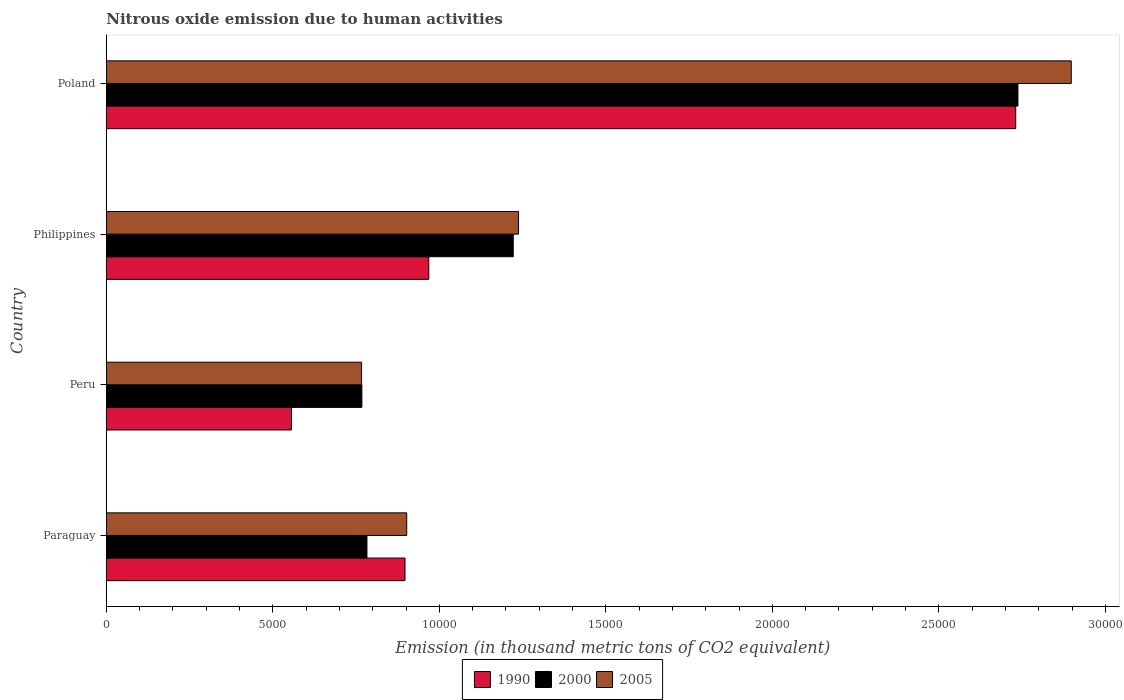Are the number of bars per tick equal to the number of legend labels?
Your answer should be very brief. Yes. How many bars are there on the 2nd tick from the bottom?
Your answer should be compact. 3. What is the label of the 2nd group of bars from the top?
Your answer should be very brief. Philippines. What is the amount of nitrous oxide emitted in 2000 in Philippines?
Ensure brevity in your answer.  1.22e+04. Across all countries, what is the maximum amount of nitrous oxide emitted in 2005?
Keep it short and to the point. 2.90e+04. Across all countries, what is the minimum amount of nitrous oxide emitted in 1990?
Your answer should be compact. 5559.3. What is the total amount of nitrous oxide emitted in 2000 in the graph?
Ensure brevity in your answer.  5.51e+04. What is the difference between the amount of nitrous oxide emitted in 2000 in Philippines and that in Poland?
Provide a short and direct response. -1.52e+04. What is the difference between the amount of nitrous oxide emitted in 2000 in Peru and the amount of nitrous oxide emitted in 2005 in Philippines?
Offer a terse response. -4704.2. What is the average amount of nitrous oxide emitted in 2005 per country?
Your answer should be very brief. 1.45e+04. What is the difference between the amount of nitrous oxide emitted in 2000 and amount of nitrous oxide emitted in 1990 in Poland?
Ensure brevity in your answer.  66.8. What is the ratio of the amount of nitrous oxide emitted in 2005 in Peru to that in Poland?
Offer a very short reply. 0.26. Is the difference between the amount of nitrous oxide emitted in 2000 in Paraguay and Poland greater than the difference between the amount of nitrous oxide emitted in 1990 in Paraguay and Poland?
Your answer should be very brief. No. What is the difference between the highest and the second highest amount of nitrous oxide emitted in 2005?
Make the answer very short. 1.66e+04. What is the difference between the highest and the lowest amount of nitrous oxide emitted in 2005?
Your answer should be very brief. 2.13e+04. What does the 3rd bar from the bottom in Poland represents?
Give a very brief answer. 2005. Is it the case that in every country, the sum of the amount of nitrous oxide emitted in 2000 and amount of nitrous oxide emitted in 1990 is greater than the amount of nitrous oxide emitted in 2005?
Provide a short and direct response. Yes. What is the difference between two consecutive major ticks on the X-axis?
Make the answer very short. 5000. Does the graph contain any zero values?
Your answer should be very brief. No. What is the title of the graph?
Your response must be concise. Nitrous oxide emission due to human activities. What is the label or title of the X-axis?
Your answer should be compact. Emission (in thousand metric tons of CO2 equivalent). What is the Emission (in thousand metric tons of CO2 equivalent) in 1990 in Paraguay?
Provide a short and direct response. 8968.7. What is the Emission (in thousand metric tons of CO2 equivalent) of 2000 in Paraguay?
Your answer should be very brief. 7826.3. What is the Emission (in thousand metric tons of CO2 equivalent) of 2005 in Paraguay?
Give a very brief answer. 9019.7. What is the Emission (in thousand metric tons of CO2 equivalent) in 1990 in Peru?
Provide a succinct answer. 5559.3. What is the Emission (in thousand metric tons of CO2 equivalent) of 2000 in Peru?
Make the answer very short. 7673.9. What is the Emission (in thousand metric tons of CO2 equivalent) in 2005 in Peru?
Make the answer very short. 7664.2. What is the Emission (in thousand metric tons of CO2 equivalent) in 1990 in Philippines?
Keep it short and to the point. 9682.8. What is the Emission (in thousand metric tons of CO2 equivalent) of 2000 in Philippines?
Your answer should be compact. 1.22e+04. What is the Emission (in thousand metric tons of CO2 equivalent) in 2005 in Philippines?
Provide a succinct answer. 1.24e+04. What is the Emission (in thousand metric tons of CO2 equivalent) of 1990 in Poland?
Offer a terse response. 2.73e+04. What is the Emission (in thousand metric tons of CO2 equivalent) in 2000 in Poland?
Give a very brief answer. 2.74e+04. What is the Emission (in thousand metric tons of CO2 equivalent) of 2005 in Poland?
Offer a very short reply. 2.90e+04. Across all countries, what is the maximum Emission (in thousand metric tons of CO2 equivalent) of 1990?
Provide a short and direct response. 2.73e+04. Across all countries, what is the maximum Emission (in thousand metric tons of CO2 equivalent) in 2000?
Your answer should be compact. 2.74e+04. Across all countries, what is the maximum Emission (in thousand metric tons of CO2 equivalent) in 2005?
Your response must be concise. 2.90e+04. Across all countries, what is the minimum Emission (in thousand metric tons of CO2 equivalent) in 1990?
Your response must be concise. 5559.3. Across all countries, what is the minimum Emission (in thousand metric tons of CO2 equivalent) of 2000?
Your response must be concise. 7673.9. Across all countries, what is the minimum Emission (in thousand metric tons of CO2 equivalent) of 2005?
Give a very brief answer. 7664.2. What is the total Emission (in thousand metric tons of CO2 equivalent) in 1990 in the graph?
Your answer should be compact. 5.15e+04. What is the total Emission (in thousand metric tons of CO2 equivalent) in 2000 in the graph?
Ensure brevity in your answer.  5.51e+04. What is the total Emission (in thousand metric tons of CO2 equivalent) of 2005 in the graph?
Provide a short and direct response. 5.80e+04. What is the difference between the Emission (in thousand metric tons of CO2 equivalent) in 1990 in Paraguay and that in Peru?
Ensure brevity in your answer.  3409.4. What is the difference between the Emission (in thousand metric tons of CO2 equivalent) of 2000 in Paraguay and that in Peru?
Make the answer very short. 152.4. What is the difference between the Emission (in thousand metric tons of CO2 equivalent) of 2005 in Paraguay and that in Peru?
Offer a terse response. 1355.5. What is the difference between the Emission (in thousand metric tons of CO2 equivalent) in 1990 in Paraguay and that in Philippines?
Ensure brevity in your answer.  -714.1. What is the difference between the Emission (in thousand metric tons of CO2 equivalent) in 2000 in Paraguay and that in Philippines?
Your response must be concise. -4392.8. What is the difference between the Emission (in thousand metric tons of CO2 equivalent) of 2005 in Paraguay and that in Philippines?
Make the answer very short. -3358.4. What is the difference between the Emission (in thousand metric tons of CO2 equivalent) in 1990 in Paraguay and that in Poland?
Give a very brief answer. -1.83e+04. What is the difference between the Emission (in thousand metric tons of CO2 equivalent) of 2000 in Paraguay and that in Poland?
Ensure brevity in your answer.  -1.95e+04. What is the difference between the Emission (in thousand metric tons of CO2 equivalent) of 2005 in Paraguay and that in Poland?
Provide a short and direct response. -2.00e+04. What is the difference between the Emission (in thousand metric tons of CO2 equivalent) of 1990 in Peru and that in Philippines?
Your response must be concise. -4123.5. What is the difference between the Emission (in thousand metric tons of CO2 equivalent) of 2000 in Peru and that in Philippines?
Provide a short and direct response. -4545.2. What is the difference between the Emission (in thousand metric tons of CO2 equivalent) in 2005 in Peru and that in Philippines?
Give a very brief answer. -4713.9. What is the difference between the Emission (in thousand metric tons of CO2 equivalent) in 1990 in Peru and that in Poland?
Your answer should be compact. -2.17e+04. What is the difference between the Emission (in thousand metric tons of CO2 equivalent) of 2000 in Peru and that in Poland?
Provide a short and direct response. -1.97e+04. What is the difference between the Emission (in thousand metric tons of CO2 equivalent) in 2005 in Peru and that in Poland?
Offer a very short reply. -2.13e+04. What is the difference between the Emission (in thousand metric tons of CO2 equivalent) of 1990 in Philippines and that in Poland?
Provide a short and direct response. -1.76e+04. What is the difference between the Emission (in thousand metric tons of CO2 equivalent) of 2000 in Philippines and that in Poland?
Your answer should be very brief. -1.52e+04. What is the difference between the Emission (in thousand metric tons of CO2 equivalent) of 2005 in Philippines and that in Poland?
Give a very brief answer. -1.66e+04. What is the difference between the Emission (in thousand metric tons of CO2 equivalent) in 1990 in Paraguay and the Emission (in thousand metric tons of CO2 equivalent) in 2000 in Peru?
Provide a succinct answer. 1294.8. What is the difference between the Emission (in thousand metric tons of CO2 equivalent) of 1990 in Paraguay and the Emission (in thousand metric tons of CO2 equivalent) of 2005 in Peru?
Provide a short and direct response. 1304.5. What is the difference between the Emission (in thousand metric tons of CO2 equivalent) in 2000 in Paraguay and the Emission (in thousand metric tons of CO2 equivalent) in 2005 in Peru?
Your answer should be compact. 162.1. What is the difference between the Emission (in thousand metric tons of CO2 equivalent) of 1990 in Paraguay and the Emission (in thousand metric tons of CO2 equivalent) of 2000 in Philippines?
Offer a terse response. -3250.4. What is the difference between the Emission (in thousand metric tons of CO2 equivalent) of 1990 in Paraguay and the Emission (in thousand metric tons of CO2 equivalent) of 2005 in Philippines?
Ensure brevity in your answer.  -3409.4. What is the difference between the Emission (in thousand metric tons of CO2 equivalent) of 2000 in Paraguay and the Emission (in thousand metric tons of CO2 equivalent) of 2005 in Philippines?
Provide a short and direct response. -4551.8. What is the difference between the Emission (in thousand metric tons of CO2 equivalent) in 1990 in Paraguay and the Emission (in thousand metric tons of CO2 equivalent) in 2000 in Poland?
Your answer should be very brief. -1.84e+04. What is the difference between the Emission (in thousand metric tons of CO2 equivalent) in 1990 in Paraguay and the Emission (in thousand metric tons of CO2 equivalent) in 2005 in Poland?
Make the answer very short. -2.00e+04. What is the difference between the Emission (in thousand metric tons of CO2 equivalent) in 2000 in Paraguay and the Emission (in thousand metric tons of CO2 equivalent) in 2005 in Poland?
Offer a terse response. -2.11e+04. What is the difference between the Emission (in thousand metric tons of CO2 equivalent) in 1990 in Peru and the Emission (in thousand metric tons of CO2 equivalent) in 2000 in Philippines?
Your answer should be compact. -6659.8. What is the difference between the Emission (in thousand metric tons of CO2 equivalent) in 1990 in Peru and the Emission (in thousand metric tons of CO2 equivalent) in 2005 in Philippines?
Provide a short and direct response. -6818.8. What is the difference between the Emission (in thousand metric tons of CO2 equivalent) of 2000 in Peru and the Emission (in thousand metric tons of CO2 equivalent) of 2005 in Philippines?
Offer a very short reply. -4704.2. What is the difference between the Emission (in thousand metric tons of CO2 equivalent) in 1990 in Peru and the Emission (in thousand metric tons of CO2 equivalent) in 2000 in Poland?
Provide a short and direct response. -2.18e+04. What is the difference between the Emission (in thousand metric tons of CO2 equivalent) in 1990 in Peru and the Emission (in thousand metric tons of CO2 equivalent) in 2005 in Poland?
Your answer should be compact. -2.34e+04. What is the difference between the Emission (in thousand metric tons of CO2 equivalent) in 2000 in Peru and the Emission (in thousand metric tons of CO2 equivalent) in 2005 in Poland?
Your response must be concise. -2.13e+04. What is the difference between the Emission (in thousand metric tons of CO2 equivalent) of 1990 in Philippines and the Emission (in thousand metric tons of CO2 equivalent) of 2000 in Poland?
Offer a terse response. -1.77e+04. What is the difference between the Emission (in thousand metric tons of CO2 equivalent) in 1990 in Philippines and the Emission (in thousand metric tons of CO2 equivalent) in 2005 in Poland?
Your answer should be compact. -1.93e+04. What is the difference between the Emission (in thousand metric tons of CO2 equivalent) of 2000 in Philippines and the Emission (in thousand metric tons of CO2 equivalent) of 2005 in Poland?
Offer a terse response. -1.68e+04. What is the average Emission (in thousand metric tons of CO2 equivalent) of 1990 per country?
Your answer should be compact. 1.29e+04. What is the average Emission (in thousand metric tons of CO2 equivalent) of 2000 per country?
Provide a succinct answer. 1.38e+04. What is the average Emission (in thousand metric tons of CO2 equivalent) of 2005 per country?
Give a very brief answer. 1.45e+04. What is the difference between the Emission (in thousand metric tons of CO2 equivalent) in 1990 and Emission (in thousand metric tons of CO2 equivalent) in 2000 in Paraguay?
Offer a terse response. 1142.4. What is the difference between the Emission (in thousand metric tons of CO2 equivalent) of 1990 and Emission (in thousand metric tons of CO2 equivalent) of 2005 in Paraguay?
Make the answer very short. -51. What is the difference between the Emission (in thousand metric tons of CO2 equivalent) of 2000 and Emission (in thousand metric tons of CO2 equivalent) of 2005 in Paraguay?
Your answer should be compact. -1193.4. What is the difference between the Emission (in thousand metric tons of CO2 equivalent) in 1990 and Emission (in thousand metric tons of CO2 equivalent) in 2000 in Peru?
Provide a short and direct response. -2114.6. What is the difference between the Emission (in thousand metric tons of CO2 equivalent) in 1990 and Emission (in thousand metric tons of CO2 equivalent) in 2005 in Peru?
Make the answer very short. -2104.9. What is the difference between the Emission (in thousand metric tons of CO2 equivalent) in 2000 and Emission (in thousand metric tons of CO2 equivalent) in 2005 in Peru?
Your answer should be compact. 9.7. What is the difference between the Emission (in thousand metric tons of CO2 equivalent) of 1990 and Emission (in thousand metric tons of CO2 equivalent) of 2000 in Philippines?
Your answer should be very brief. -2536.3. What is the difference between the Emission (in thousand metric tons of CO2 equivalent) of 1990 and Emission (in thousand metric tons of CO2 equivalent) of 2005 in Philippines?
Offer a very short reply. -2695.3. What is the difference between the Emission (in thousand metric tons of CO2 equivalent) of 2000 and Emission (in thousand metric tons of CO2 equivalent) of 2005 in Philippines?
Ensure brevity in your answer.  -159. What is the difference between the Emission (in thousand metric tons of CO2 equivalent) in 1990 and Emission (in thousand metric tons of CO2 equivalent) in 2000 in Poland?
Your answer should be very brief. -66.8. What is the difference between the Emission (in thousand metric tons of CO2 equivalent) of 1990 and Emission (in thousand metric tons of CO2 equivalent) of 2005 in Poland?
Your answer should be compact. -1667.4. What is the difference between the Emission (in thousand metric tons of CO2 equivalent) in 2000 and Emission (in thousand metric tons of CO2 equivalent) in 2005 in Poland?
Your answer should be compact. -1600.6. What is the ratio of the Emission (in thousand metric tons of CO2 equivalent) of 1990 in Paraguay to that in Peru?
Provide a succinct answer. 1.61. What is the ratio of the Emission (in thousand metric tons of CO2 equivalent) of 2000 in Paraguay to that in Peru?
Make the answer very short. 1.02. What is the ratio of the Emission (in thousand metric tons of CO2 equivalent) in 2005 in Paraguay to that in Peru?
Offer a terse response. 1.18. What is the ratio of the Emission (in thousand metric tons of CO2 equivalent) in 1990 in Paraguay to that in Philippines?
Your response must be concise. 0.93. What is the ratio of the Emission (in thousand metric tons of CO2 equivalent) in 2000 in Paraguay to that in Philippines?
Your answer should be very brief. 0.64. What is the ratio of the Emission (in thousand metric tons of CO2 equivalent) of 2005 in Paraguay to that in Philippines?
Give a very brief answer. 0.73. What is the ratio of the Emission (in thousand metric tons of CO2 equivalent) in 1990 in Paraguay to that in Poland?
Provide a succinct answer. 0.33. What is the ratio of the Emission (in thousand metric tons of CO2 equivalent) of 2000 in Paraguay to that in Poland?
Ensure brevity in your answer.  0.29. What is the ratio of the Emission (in thousand metric tons of CO2 equivalent) of 2005 in Paraguay to that in Poland?
Offer a terse response. 0.31. What is the ratio of the Emission (in thousand metric tons of CO2 equivalent) in 1990 in Peru to that in Philippines?
Your response must be concise. 0.57. What is the ratio of the Emission (in thousand metric tons of CO2 equivalent) in 2000 in Peru to that in Philippines?
Your response must be concise. 0.63. What is the ratio of the Emission (in thousand metric tons of CO2 equivalent) in 2005 in Peru to that in Philippines?
Ensure brevity in your answer.  0.62. What is the ratio of the Emission (in thousand metric tons of CO2 equivalent) in 1990 in Peru to that in Poland?
Keep it short and to the point. 0.2. What is the ratio of the Emission (in thousand metric tons of CO2 equivalent) in 2000 in Peru to that in Poland?
Your answer should be very brief. 0.28. What is the ratio of the Emission (in thousand metric tons of CO2 equivalent) in 2005 in Peru to that in Poland?
Ensure brevity in your answer.  0.26. What is the ratio of the Emission (in thousand metric tons of CO2 equivalent) of 1990 in Philippines to that in Poland?
Provide a succinct answer. 0.35. What is the ratio of the Emission (in thousand metric tons of CO2 equivalent) of 2000 in Philippines to that in Poland?
Offer a terse response. 0.45. What is the ratio of the Emission (in thousand metric tons of CO2 equivalent) of 2005 in Philippines to that in Poland?
Offer a very short reply. 0.43. What is the difference between the highest and the second highest Emission (in thousand metric tons of CO2 equivalent) of 1990?
Offer a terse response. 1.76e+04. What is the difference between the highest and the second highest Emission (in thousand metric tons of CO2 equivalent) in 2000?
Keep it short and to the point. 1.52e+04. What is the difference between the highest and the second highest Emission (in thousand metric tons of CO2 equivalent) in 2005?
Your answer should be compact. 1.66e+04. What is the difference between the highest and the lowest Emission (in thousand metric tons of CO2 equivalent) in 1990?
Ensure brevity in your answer.  2.17e+04. What is the difference between the highest and the lowest Emission (in thousand metric tons of CO2 equivalent) in 2000?
Keep it short and to the point. 1.97e+04. What is the difference between the highest and the lowest Emission (in thousand metric tons of CO2 equivalent) in 2005?
Make the answer very short. 2.13e+04. 